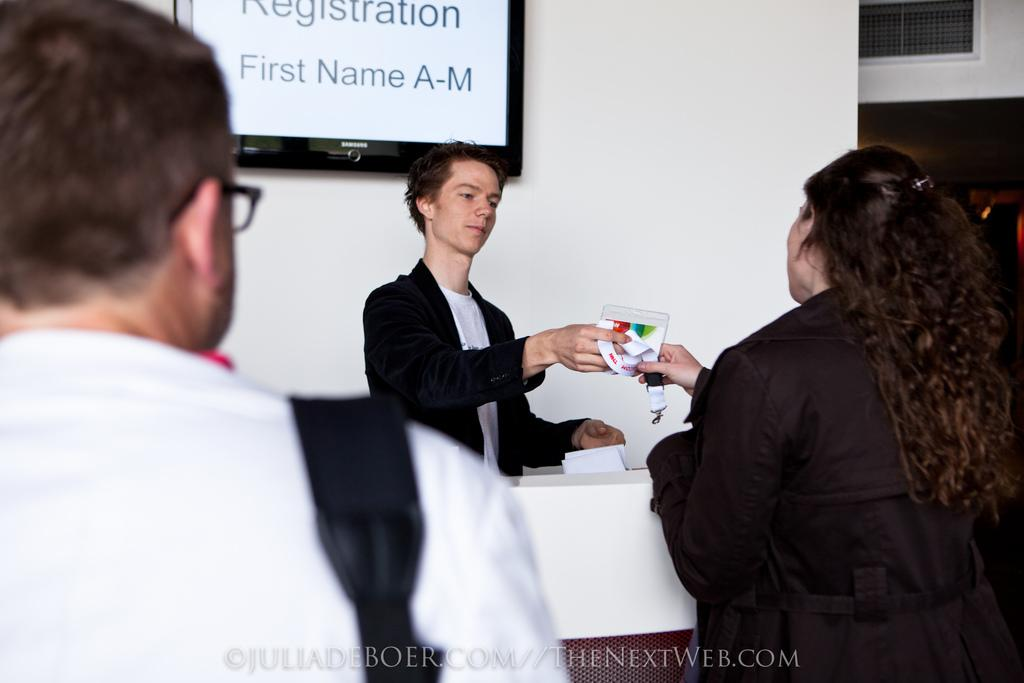How many people are present in the image? There are three people in the image. What are two of the people doing with an ID card? Two of the people are holding an ID card. What type of items can be seen in the image besides the people and the ID card? There are papers, spectacles, a television on the wall, a mesh, and some unspecified objects in the image. Can you tell me how many toes are visible on the people in the image? There is no information about the people's toes in the image, so it cannot be determined. 